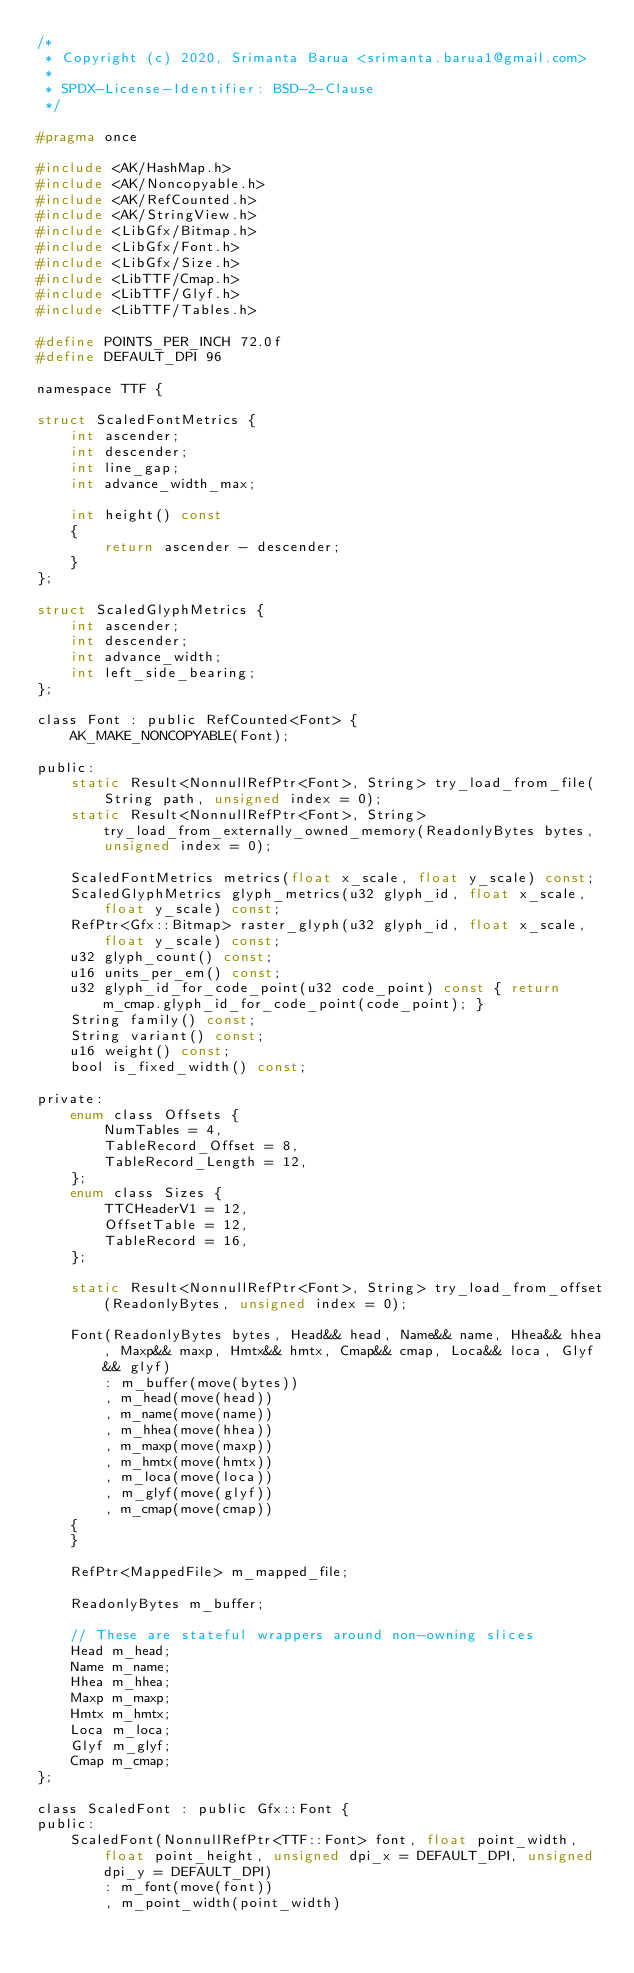Convert code to text. <code><loc_0><loc_0><loc_500><loc_500><_C_>/*
 * Copyright (c) 2020, Srimanta Barua <srimanta.barua1@gmail.com>
 *
 * SPDX-License-Identifier: BSD-2-Clause
 */

#pragma once

#include <AK/HashMap.h>
#include <AK/Noncopyable.h>
#include <AK/RefCounted.h>
#include <AK/StringView.h>
#include <LibGfx/Bitmap.h>
#include <LibGfx/Font.h>
#include <LibGfx/Size.h>
#include <LibTTF/Cmap.h>
#include <LibTTF/Glyf.h>
#include <LibTTF/Tables.h>

#define POINTS_PER_INCH 72.0f
#define DEFAULT_DPI 96

namespace TTF {

struct ScaledFontMetrics {
    int ascender;
    int descender;
    int line_gap;
    int advance_width_max;

    int height() const
    {
        return ascender - descender;
    }
};

struct ScaledGlyphMetrics {
    int ascender;
    int descender;
    int advance_width;
    int left_side_bearing;
};

class Font : public RefCounted<Font> {
    AK_MAKE_NONCOPYABLE(Font);

public:
    static Result<NonnullRefPtr<Font>, String> try_load_from_file(String path, unsigned index = 0);
    static Result<NonnullRefPtr<Font>, String> try_load_from_externally_owned_memory(ReadonlyBytes bytes, unsigned index = 0);

    ScaledFontMetrics metrics(float x_scale, float y_scale) const;
    ScaledGlyphMetrics glyph_metrics(u32 glyph_id, float x_scale, float y_scale) const;
    RefPtr<Gfx::Bitmap> raster_glyph(u32 glyph_id, float x_scale, float y_scale) const;
    u32 glyph_count() const;
    u16 units_per_em() const;
    u32 glyph_id_for_code_point(u32 code_point) const { return m_cmap.glyph_id_for_code_point(code_point); }
    String family() const;
    String variant() const;
    u16 weight() const;
    bool is_fixed_width() const;

private:
    enum class Offsets {
        NumTables = 4,
        TableRecord_Offset = 8,
        TableRecord_Length = 12,
    };
    enum class Sizes {
        TTCHeaderV1 = 12,
        OffsetTable = 12,
        TableRecord = 16,
    };

    static Result<NonnullRefPtr<Font>, String> try_load_from_offset(ReadonlyBytes, unsigned index = 0);

    Font(ReadonlyBytes bytes, Head&& head, Name&& name, Hhea&& hhea, Maxp&& maxp, Hmtx&& hmtx, Cmap&& cmap, Loca&& loca, Glyf&& glyf)
        : m_buffer(move(bytes))
        , m_head(move(head))
        , m_name(move(name))
        , m_hhea(move(hhea))
        , m_maxp(move(maxp))
        , m_hmtx(move(hmtx))
        , m_loca(move(loca))
        , m_glyf(move(glyf))
        , m_cmap(move(cmap))
    {
    }

    RefPtr<MappedFile> m_mapped_file;

    ReadonlyBytes m_buffer;

    // These are stateful wrappers around non-owning slices
    Head m_head;
    Name m_name;
    Hhea m_hhea;
    Maxp m_maxp;
    Hmtx m_hmtx;
    Loca m_loca;
    Glyf m_glyf;
    Cmap m_cmap;
};

class ScaledFont : public Gfx::Font {
public:
    ScaledFont(NonnullRefPtr<TTF::Font> font, float point_width, float point_height, unsigned dpi_x = DEFAULT_DPI, unsigned dpi_y = DEFAULT_DPI)
        : m_font(move(font))
        , m_point_width(point_width)</code> 